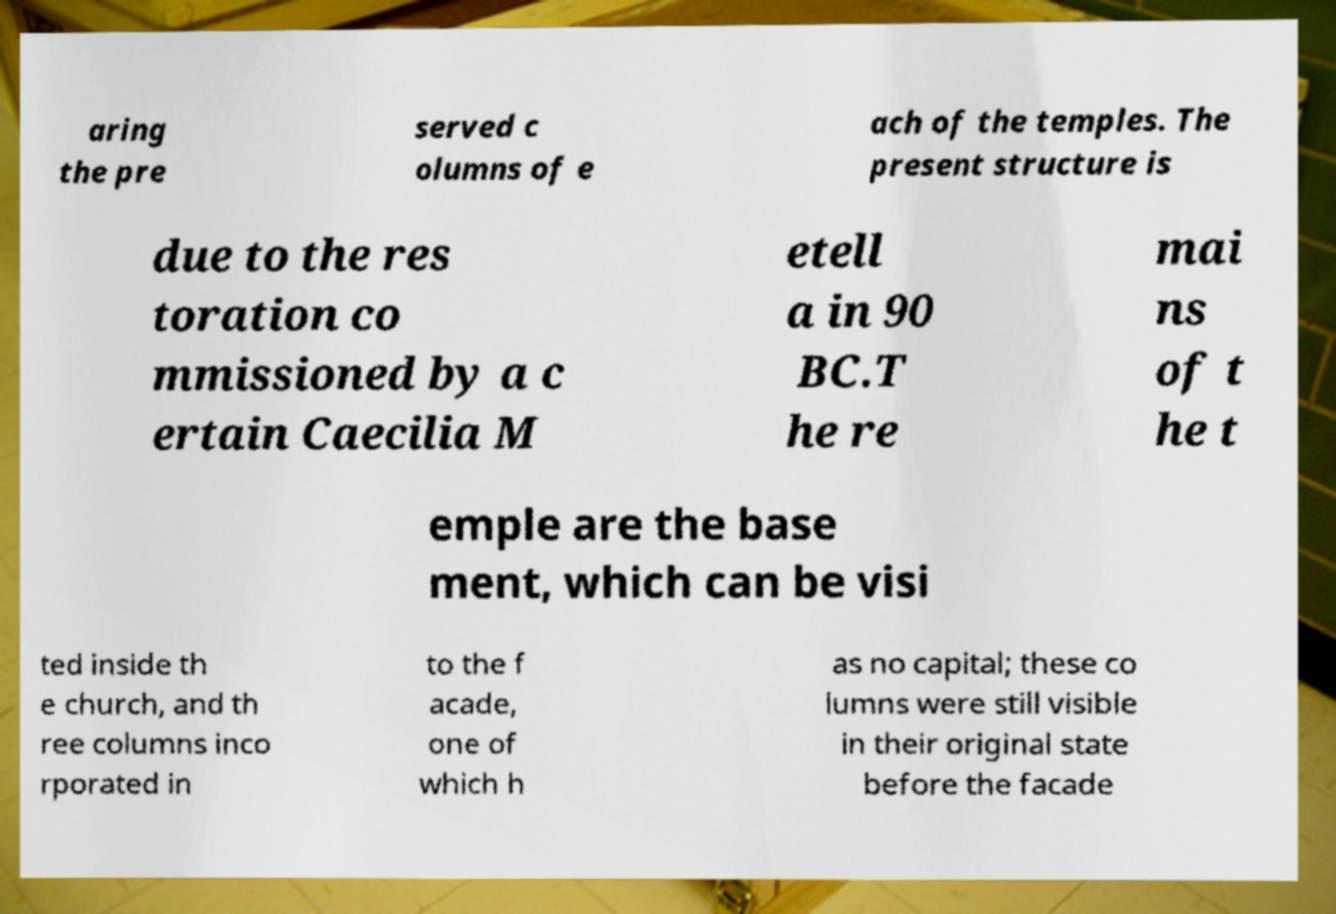What messages or text are displayed in this image? I need them in a readable, typed format. aring the pre served c olumns of e ach of the temples. The present structure is due to the res toration co mmissioned by a c ertain Caecilia M etell a in 90 BC.T he re mai ns of t he t emple are the base ment, which can be visi ted inside th e church, and th ree columns inco rporated in to the f acade, one of which h as no capital; these co lumns were still visible in their original state before the facade 